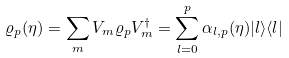<formula> <loc_0><loc_0><loc_500><loc_500>\varrho _ { p } ( \eta ) & = \sum _ { m } V _ { m } \varrho _ { p } V _ { m } ^ { \dag } = \sum _ { l = 0 } ^ { p } \alpha _ { l , p } ( \eta ) | l \rangle \langle l |</formula> 